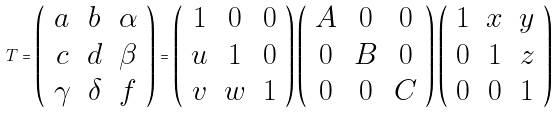<formula> <loc_0><loc_0><loc_500><loc_500>T = \left ( \begin{array} { c c c } a & b & \alpha \\ c & d & \beta \\ \gamma & \delta & f \end{array} \right ) = \left ( \begin{array} { c c c } 1 & 0 & 0 \\ u & 1 & 0 \\ v & w & 1 \end{array} \right ) \left ( \begin{array} { c c c } A & 0 & 0 \\ 0 & B & 0 \\ 0 & 0 & C \end{array} \right ) \left ( \begin{array} { c c c } 1 & x & y \\ 0 & 1 & z \\ 0 & 0 & 1 \end{array} \right )</formula> 